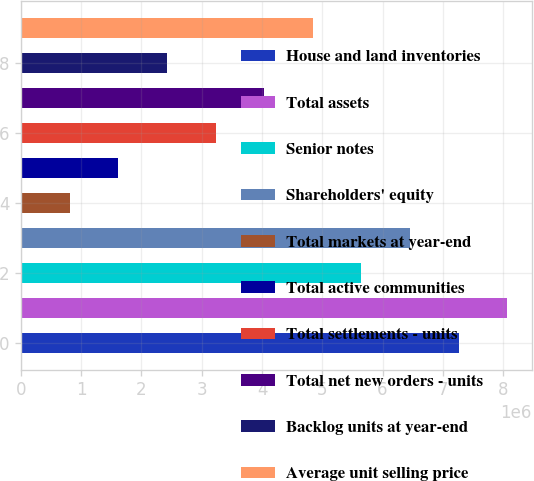Convert chart. <chart><loc_0><loc_0><loc_500><loc_500><bar_chart><fcel>House and land inventories<fcel>Total assets<fcel>Senior notes<fcel>Shareholders' equity<fcel>Total markets at year-end<fcel>Total active communities<fcel>Total settlements - units<fcel>Total net new orders - units<fcel>Backlog units at year-end<fcel>Average unit selling price<nl><fcel>7.26494e+06<fcel>8.07215e+06<fcel>5.65051e+06<fcel>6.45772e+06<fcel>807234<fcel>1.61445e+06<fcel>3.22887e+06<fcel>4.03609e+06<fcel>2.42166e+06<fcel>4.8433e+06<nl></chart> 